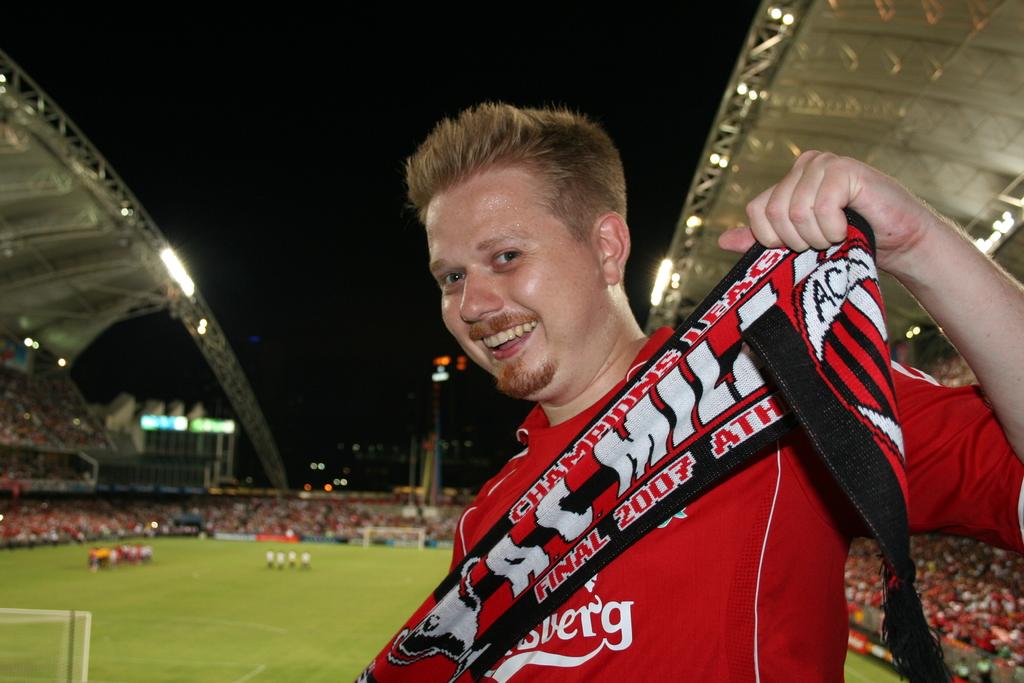What two letters are written in black on the right side of the scarf?
Ensure brevity in your answer.  Ac. What is the year of the garment the man is holding up?
Provide a succinct answer. 2007. 